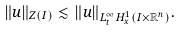Convert formula to latex. <formula><loc_0><loc_0><loc_500><loc_500>\| u \| _ { Z ( I ) } \lesssim \| u \| _ { L ^ { \infty } _ { t } H _ { x } ^ { 1 } ( I \times \mathbb { R } ^ { n } ) } .</formula> 